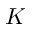<formula> <loc_0><loc_0><loc_500><loc_500>K</formula> 